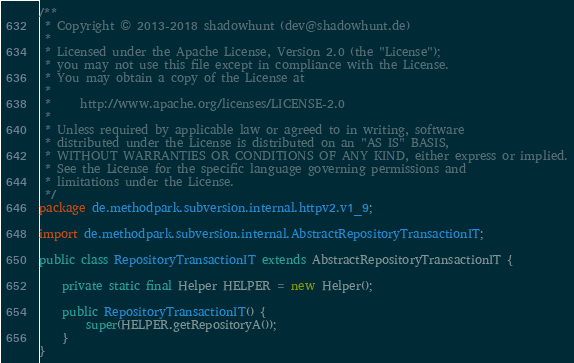Convert code to text. <code><loc_0><loc_0><loc_500><loc_500><_Java_>/**
 * Copyright © 2013-2018 shadowhunt (dev@shadowhunt.de)
 *
 * Licensed under the Apache License, Version 2.0 (the "License");
 * you may not use this file except in compliance with the License.
 * You may obtain a copy of the License at
 *
 *     http://www.apache.org/licenses/LICENSE-2.0
 *
 * Unless required by applicable law or agreed to in writing, software
 * distributed under the License is distributed on an "AS IS" BASIS,
 * WITHOUT WARRANTIES OR CONDITIONS OF ANY KIND, either express or implied.
 * See the License for the specific language governing permissions and
 * limitations under the License.
 */
package de.methodpark.subversion.internal.httpv2.v1_9;

import de.methodpark.subversion.internal.AbstractRepositoryTransactionIT;

public class RepositoryTransactionIT extends AbstractRepositoryTransactionIT {

    private static final Helper HELPER = new Helper();

    public RepositoryTransactionIT() {
        super(HELPER.getRepositoryA());
    }
}
</code> 